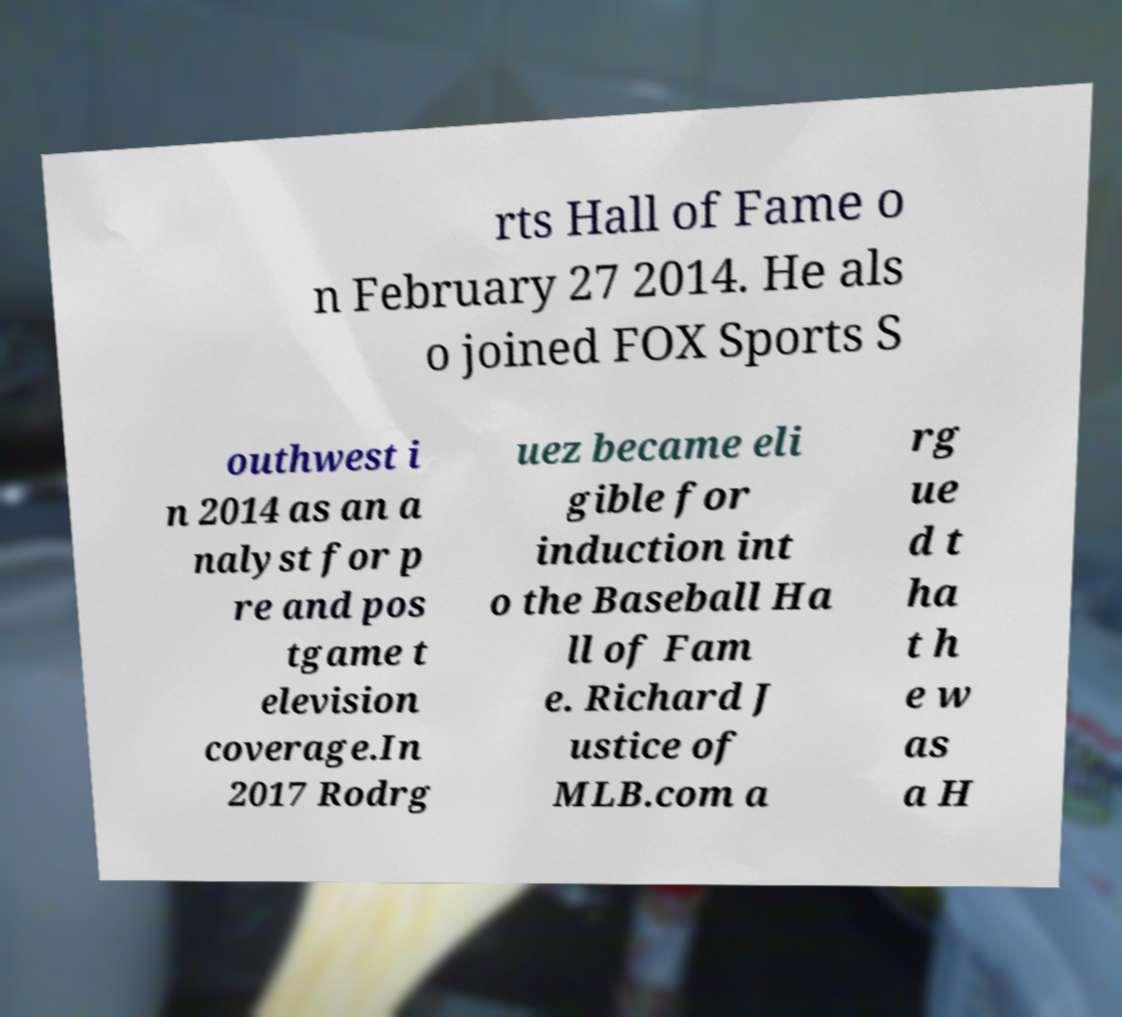For documentation purposes, I need the text within this image transcribed. Could you provide that? rts Hall of Fame o n February 27 2014. He als o joined FOX Sports S outhwest i n 2014 as an a nalyst for p re and pos tgame t elevision coverage.In 2017 Rodrg uez became eli gible for induction int o the Baseball Ha ll of Fam e. Richard J ustice of MLB.com a rg ue d t ha t h e w as a H 